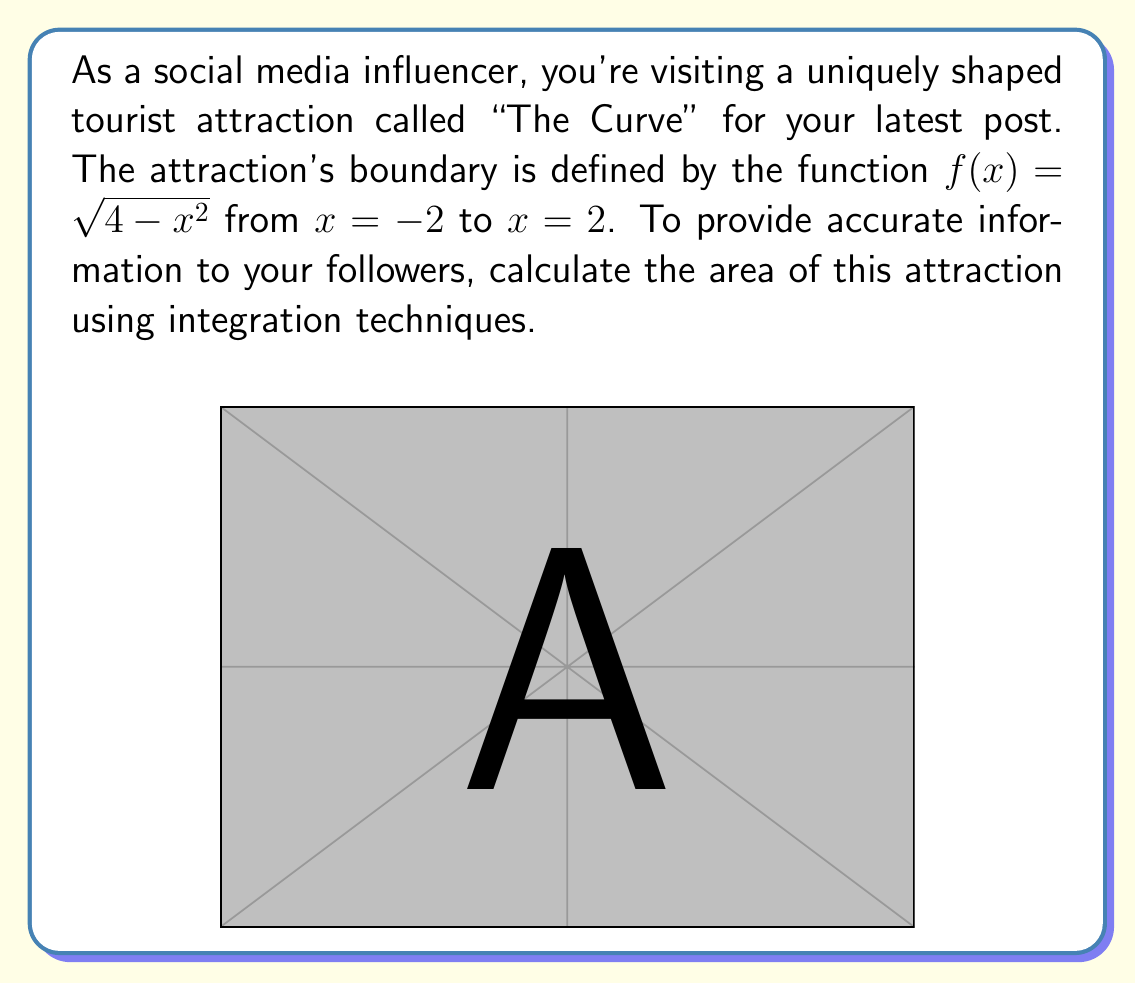Help me with this question. To calculate the area of this irregularly shaped tourist attraction, we need to use integration. The area under a curve $f(x)$ from $a$ to $b$ is given by the definite integral:

$$ A = \int_a^b f(x) dx $$

In this case, we have:
$f(x) = \sqrt{4-x^2}$
$a = -2$
$b = 2$

So, our integral becomes:

$$ A = \int_{-2}^2 \sqrt{4-x^2} dx $$

This integral represents a quarter of a circle with radius 2. We can solve it using trigonometric substitution:

Let $x = 2\sin\theta$. Then $dx = 2\cos\theta d\theta$

When $x = -2$, $\theta = -\frac{\pi}{2}$
When $x = 2$, $\theta = \frac{\pi}{2}$

Substituting:

$$ A = \int_{-\frac{\pi}{2}}^{\frac{\pi}{2}} \sqrt{4-(2\sin\theta)^2} \cdot 2\cos\theta d\theta $$
$$ = \int_{-\frac{\pi}{2}}^{\frac{\pi}{2}} \sqrt{4-4\sin^2\theta} \cdot 2\cos\theta d\theta $$
$$ = \int_{-\frac{\pi}{2}}^{\frac{\pi}{2}} 2\sqrt{\cos^2\theta} \cdot 2\cos\theta d\theta $$
$$ = 4\int_{-\frac{\pi}{2}}^{\frac{\pi}{2}} \cos^2\theta d\theta $$

Using the identity $\cos^2\theta = \frac{1+\cos(2\theta)}{2}$:

$$ A = 4\int_{-\frac{\pi}{2}}^{\frac{\pi}{2}} \frac{1+\cos(2\theta)}{2} d\theta $$
$$ = 2\int_{-\frac{\pi}{2}}^{\frac{\pi}{2}} (1+\cos(2\theta)) d\theta $$
$$ = 2[\theta + \frac{1}{2}\sin(2\theta)]_{-\frac{\pi}{2}}^{\frac{\pi}{2}} $$
$$ = 2[(\frac{\pi}{2} + 0) - (-\frac{\pi}{2} + 0)] $$
$$ = 2\pi $$

Therefore, the area of the tourist attraction "The Curve" is $2\pi$ square units.
Answer: $2\pi$ square units 